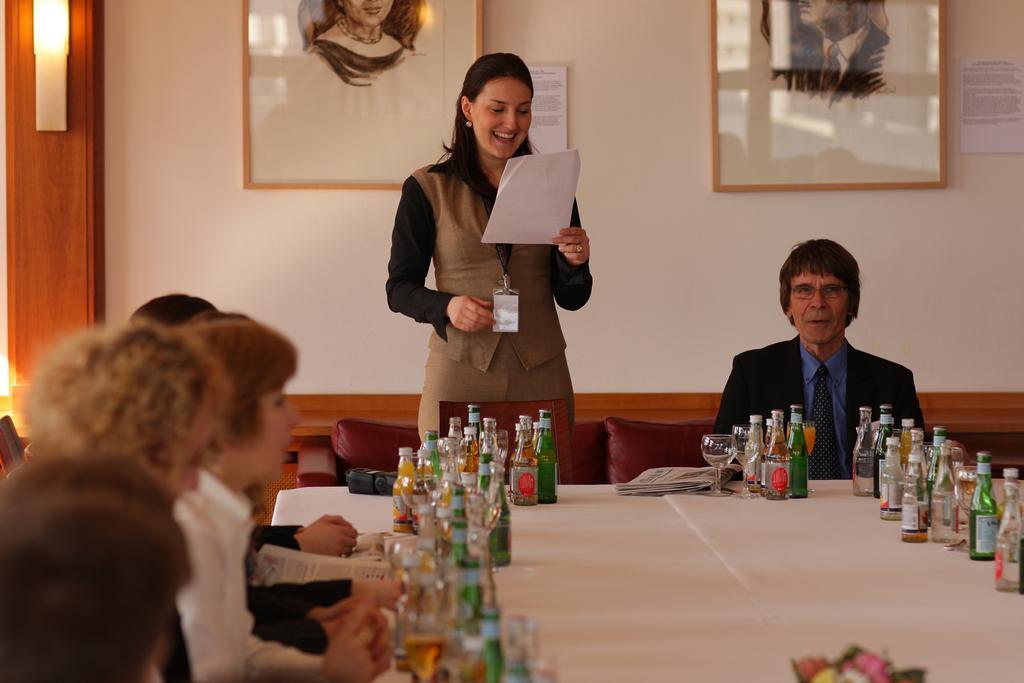Can you describe this image briefly? This picture describes about group of people they are all seated on the chair except one woman in the middle of the image the woman holding a piece of paper in front of them we can see bunch of bottles on the table behind them we can find wall paintings. 